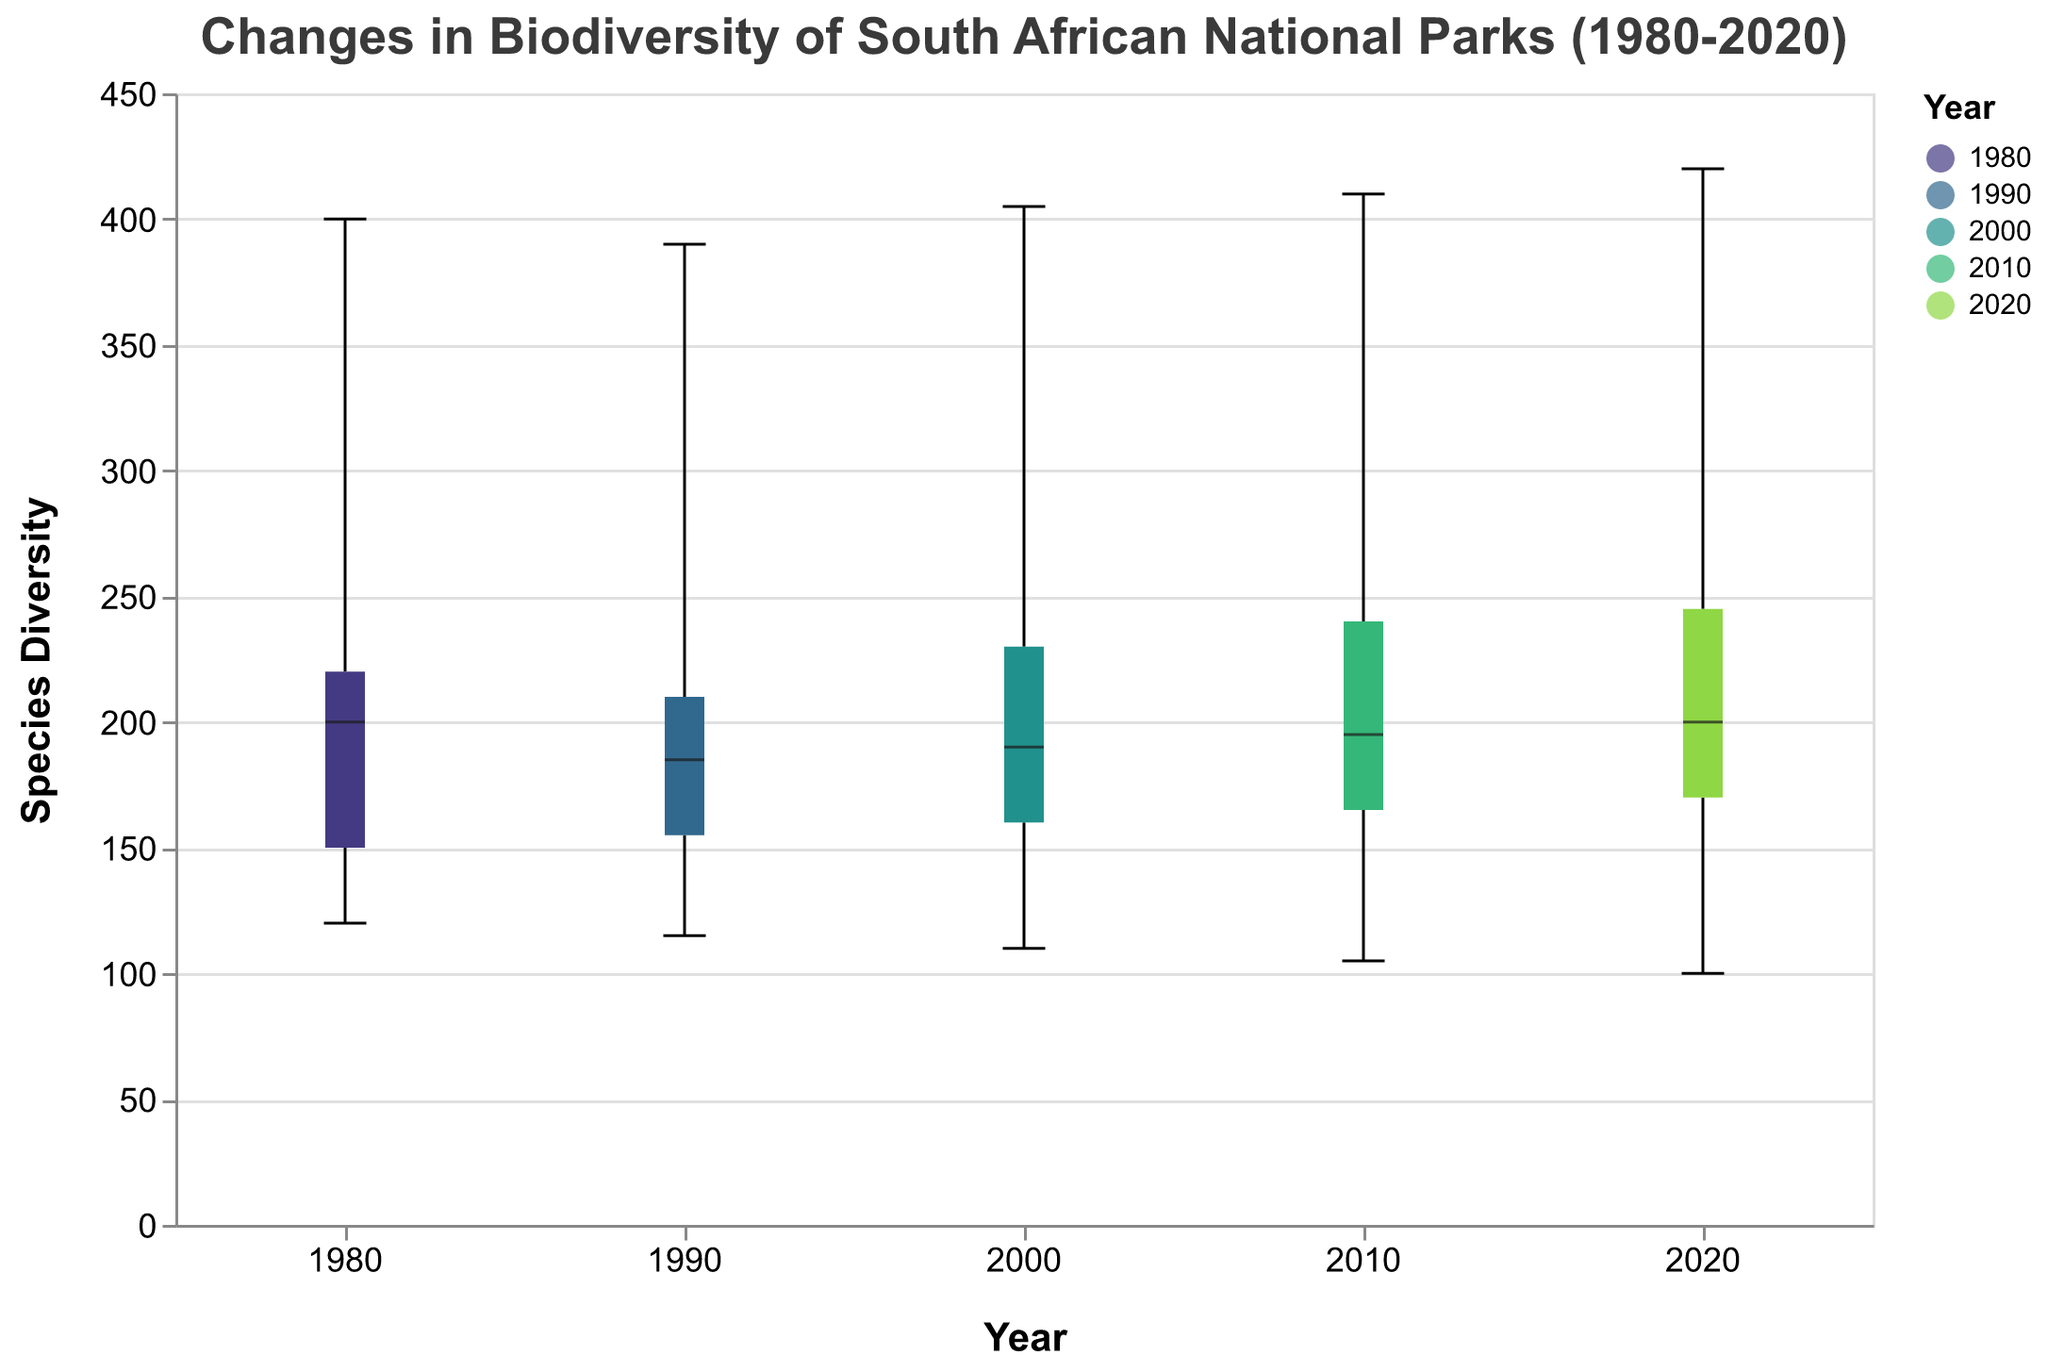What is the title of the figure? The title is typically located at the top of the figure and provides an overview of the data being presented. According to the code provided, the title is "Changes in Biodiversity of South African National Parks (1980-2020)."
Answer: Changes in Biodiversity of South African National Parks (1980-2020) What does the y-axis represent in the figure? The y-axis usually represents the dependent variable being analyzed. According to the code, the y-axis represents "Species Diversity" in this figure.
Answer: Species Diversity Which year shows the highest median species diversity? To find the highest median species diversity, observe the median lines marked in the center of each box. The year with the highest median is 2020, with Kruger National Park having the highest species diversity.
Answer: 2020 Which park has the lowest species diversity in 2010? To identify the park with the lowest species diversity in 2010, look at the lower range (whisker) of the respective 2010 boxplots. The lowest species diversity is in Augrabies Falls National Park with a value of 105.
Answer: Augrabies Falls National Park How has the species diversity in Augrabies Falls National Park changed from 1980 to 2020? To understand the change in species diversity over time, observe the value lines for Augrabies Falls National Park across different years. From 1980 (120) to 2020 (100), there's a consistent decline.
Answer: It has declined What is the range of species diversity in Table Mountain National Park in 2000? The range is calculated by subtracting the lowest value from the highest value in the boxplot for that year. For Table Mountain National Park in 2000, the upper whisker is at 230 and the lower whisker is at 230, so the range is 230 - 230 = 0.
Answer: 0 In which decade did the Addo Elephant National Park see the most significant increase in species diversity? Track the upward changes in the median line of the boxplot across the decades. For Addo Elephant National Park, the median increases from 155 (1990) to 160 (2000) and from 160 (2000) to 165 (2010) and finally to 170 (2020). The most significant increase is from 1990 to 2000.
Answer: 1990 to 2000 Which year does KwaZulu-Natal's iSimangaliso Wetland Park have equal diversity to its species diversity in 1980? Look at the boxplot for the year 1980 and note the species diversity for iSimangaliso Wetland Park (200). Cross-reference other years: it matches the species diversity in 2020.
Answer: 2020 What is the interquartile range (IQR) for species diversity in Kruger National Park in 2010? The IQR is calculated as the range between the first quartile (Q1) and the third quartile (Q3) values. For Kruger National Park in 2010, both Q1 and Q3 are at 410, thus IQR = 410 - 410 = 0.
Answer: 0 Which park shows the most variability in species diversity over the years? To determine variability, assess the spread of the values in the boxplots. The park with the widest range across the whiskers/boxes would be Kruger National Park, showing wide dispersion in 1980 (400-420), 1990 (390-420), and 2000-2020.
Answer: Kruger National Park 